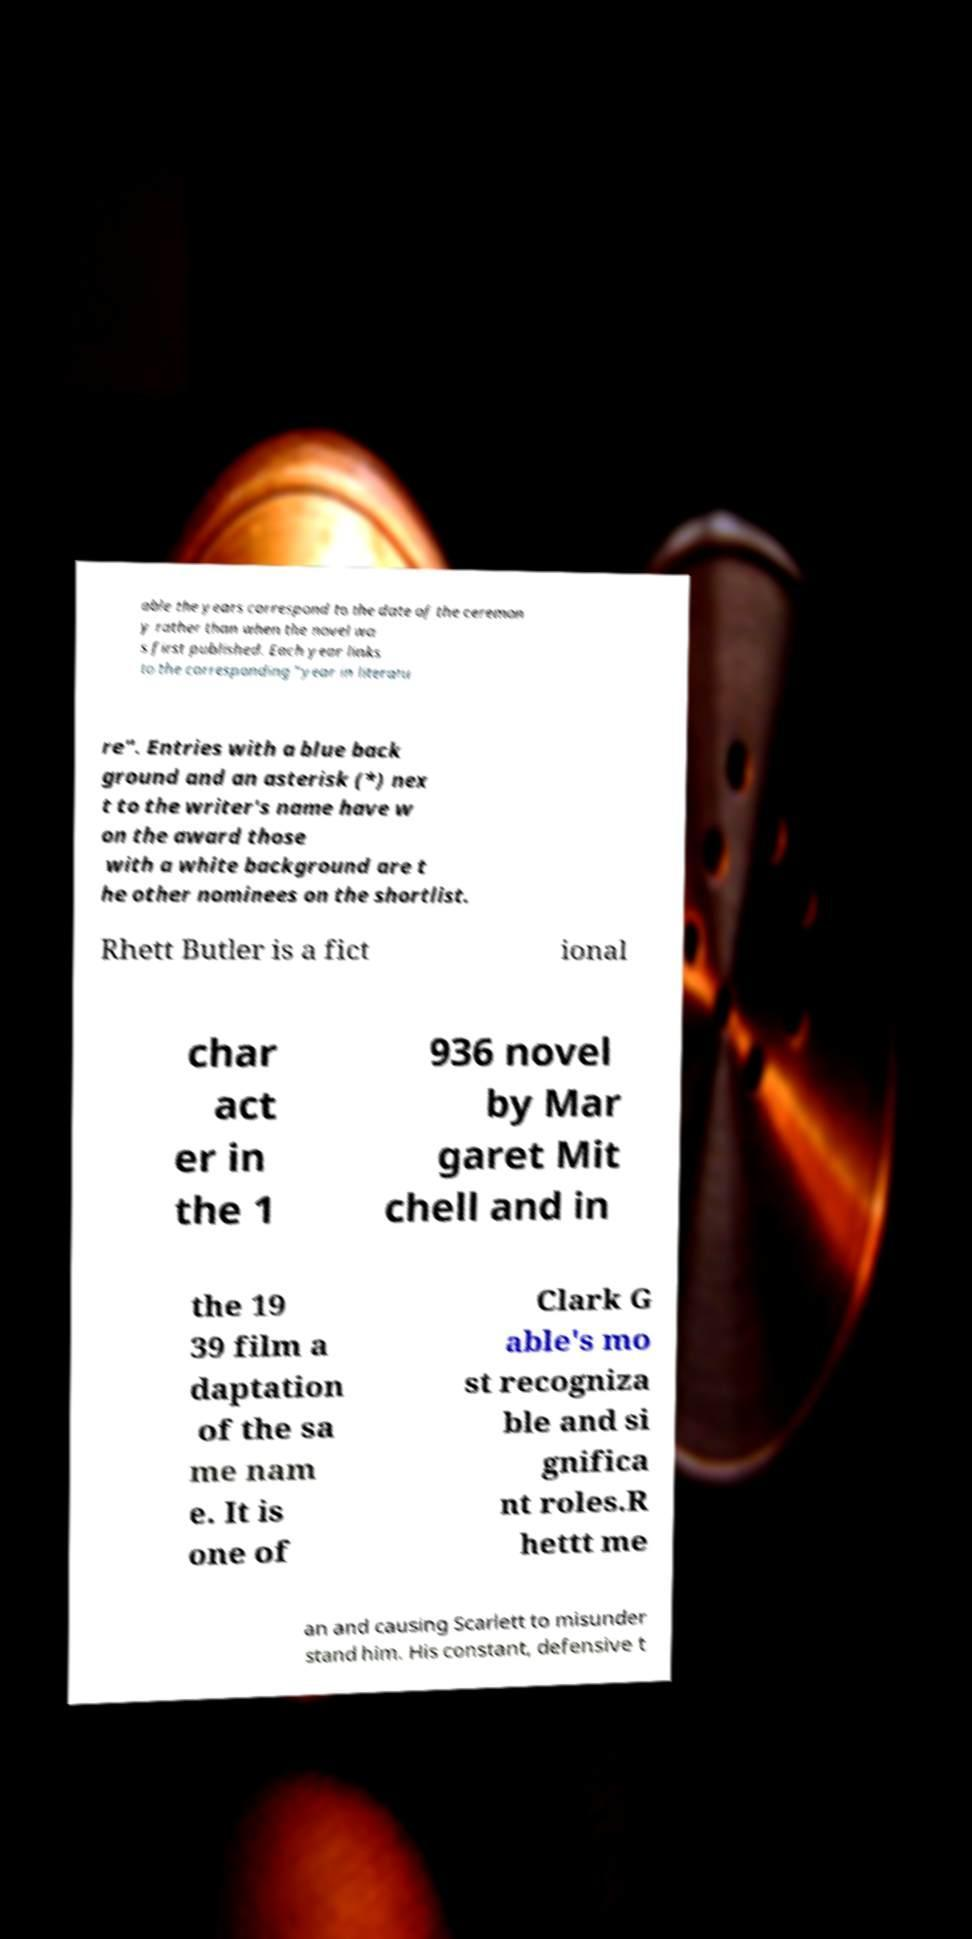What messages or text are displayed in this image? I need them in a readable, typed format. able the years correspond to the date of the ceremon y rather than when the novel wa s first published. Each year links to the corresponding "year in literatu re". Entries with a blue back ground and an asterisk (*) nex t to the writer's name have w on the award those with a white background are t he other nominees on the shortlist. Rhett Butler is a fict ional char act er in the 1 936 novel by Mar garet Mit chell and in the 19 39 film a daptation of the sa me nam e. It is one of Clark G able's mo st recogniza ble and si gnifica nt roles.R hettt me an and causing Scarlett to misunder stand him. His constant, defensive t 